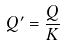Convert formula to latex. <formula><loc_0><loc_0><loc_500><loc_500>Q ^ { \prime } = \frac { Q } { K }</formula> 